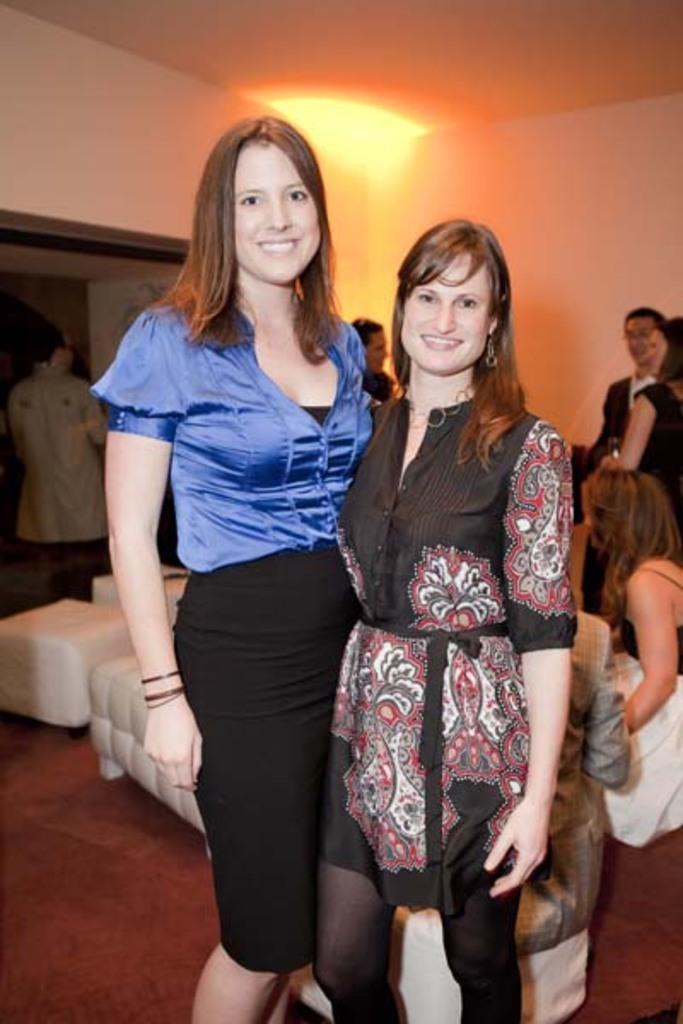Could you give a brief overview of what you see in this image? The picture is clicked inside a room. In the foreground of the picture there are two women standing, they both are smiling. In the center the picture there are couches and people standing. On the right there is a woman sitting. In the background there is a light. The walls are painted white. The floor is covered with red colored carpet. 